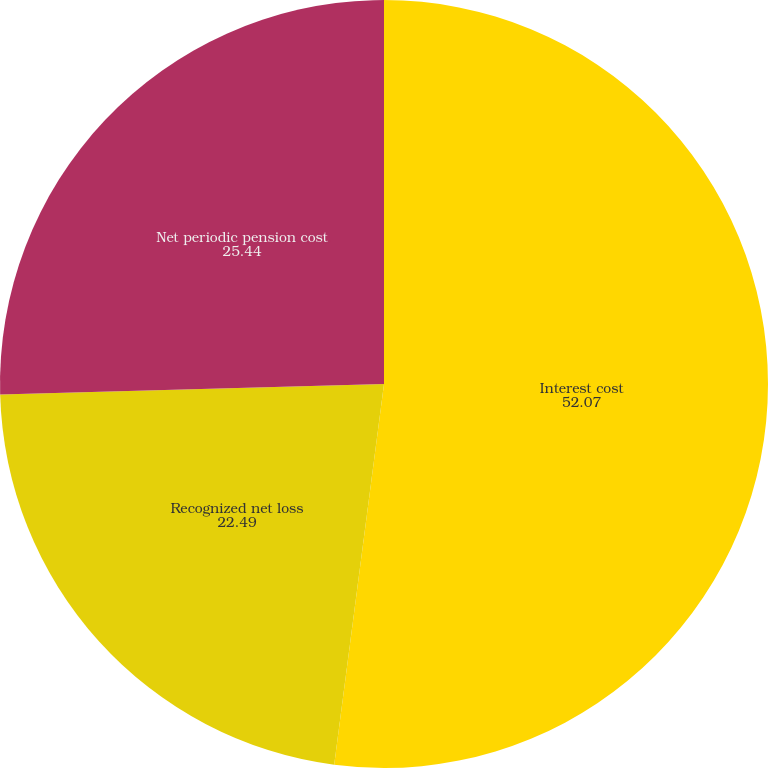Convert chart to OTSL. <chart><loc_0><loc_0><loc_500><loc_500><pie_chart><fcel>Interest cost<fcel>Recognized net loss<fcel>Net periodic pension cost<nl><fcel>52.07%<fcel>22.49%<fcel>25.44%<nl></chart> 